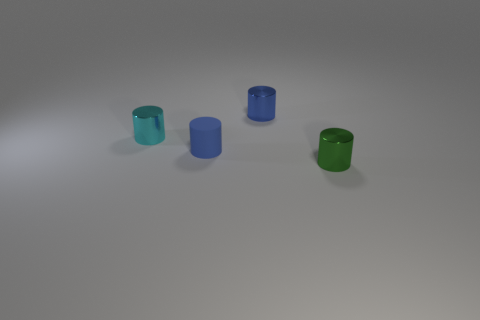Add 3 tiny blue matte things. How many objects exist? 7 Subtract all tiny green metal cylinders. How many cylinders are left? 3 Subtract 3 cylinders. How many cylinders are left? 1 Subtract all yellow blocks. How many blue cylinders are left? 2 Subtract all green cylinders. How many cylinders are left? 3 Add 3 blue matte cylinders. How many blue matte cylinders are left? 4 Add 4 tiny metallic objects. How many tiny metallic objects exist? 7 Subtract 1 green cylinders. How many objects are left? 3 Subtract all cyan cylinders. Subtract all green balls. How many cylinders are left? 3 Subtract all green metal cylinders. Subtract all small shiny things. How many objects are left? 0 